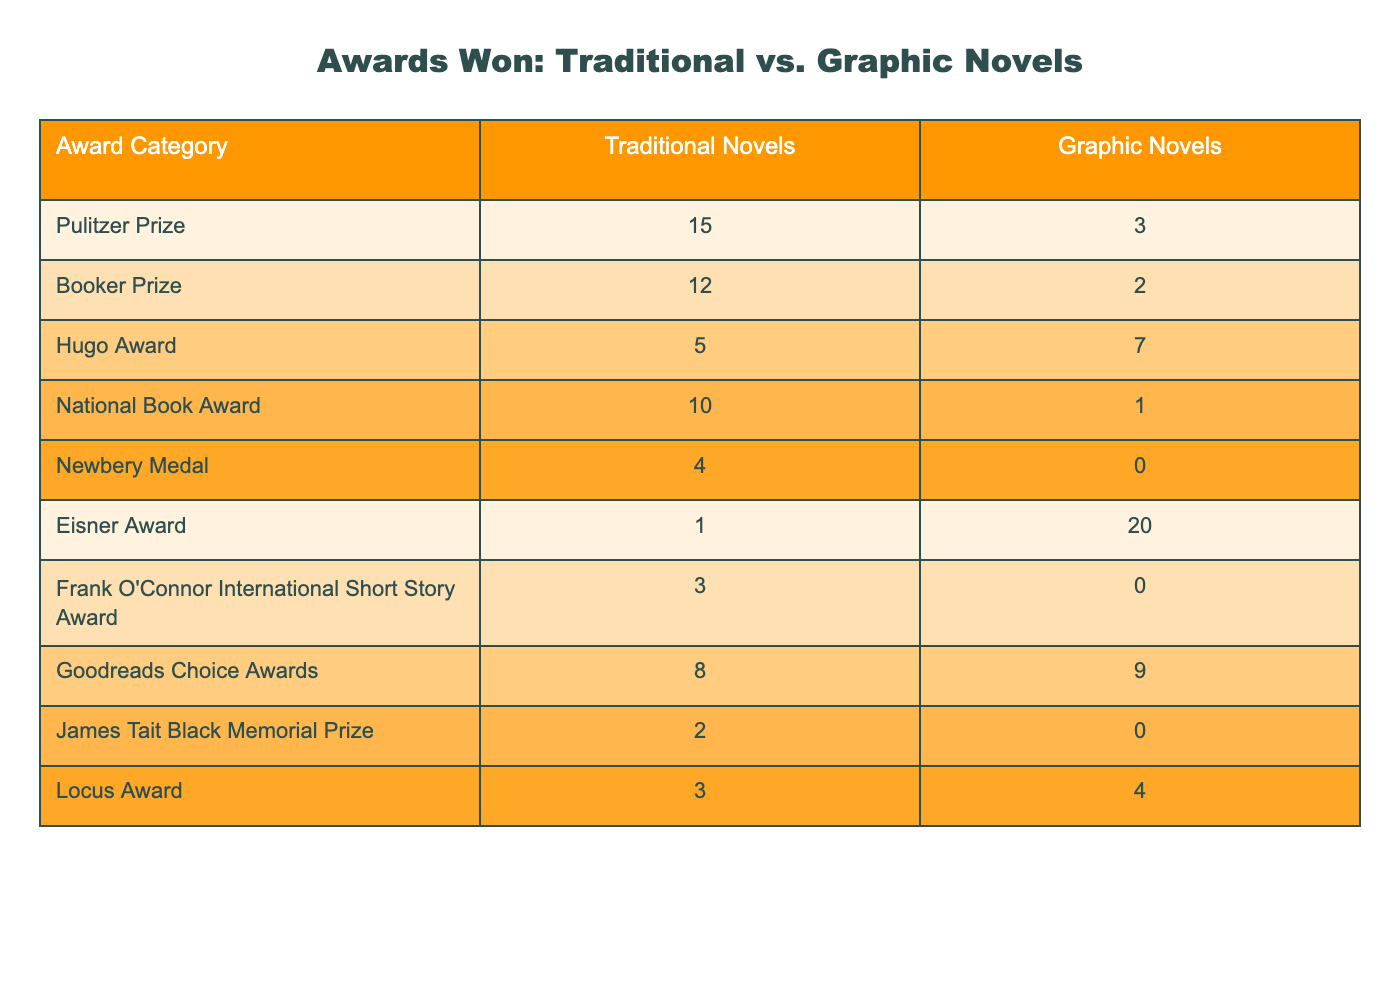What is the total number of Pulitzer Prizes won by traditional novels and graphic novels combined? The table shows that traditional novels won 15 Pulitzer Prizes and graphic novels won 3. Adding those values together (15 + 3) gives a total of 18.
Answer: 18 Which category has the highest number of awards won by traditional novels? By examining the table, the Pulitzer Prize category has the highest count of 15 awards won by traditional novels, compared to other categories listed.
Answer: Pulitzer Prize What is the difference in the number of Hugo Awards won between graphic novels and traditional novels? Looking at the table, graphic novels won 7 Hugo Awards while traditional novels won 5. The difference is calculated by subtracting the number of traditional novel awards from graphic novel awards (7 - 5), resulting in 2 more awards won by graphic novels.
Answer: 2 Did traditional novels win any Eisner Awards? The table indicates that traditional novels won 1 Eisner Award. Therefore, the answer is yes, traditional novels did win awards in this category.
Answer: Yes What is the average number of awards won by traditional novels across all categories listed? To calculate the average, add the number of awards won in all categories by traditional novels: 15 + 12 + 5 + 10 + 4 + 1 + 3 + 8 + 2 + 3 = 63. Then, divide by the number of categories, which is 10, to find the average: 63 / 10 = 6.3.
Answer: 6.3 Which type of novel won the most National Book Awards? From the table, traditional novels won 10 National Book Awards and graphic novels won 1 award in this category. Hence, traditional novels won the most.
Answer: Traditional novels What proportion of the total Goodreads Choice Awards won were by graphic novels? The table shows that graphic novels won 9 out of the total 8 + 9 = 17 Goodreads Choice Awards. The proportion can be calculated by dividing the number won by graphic novels (9) by the total (17), giving us 9/17, which is approximately 0.529 or 52.9%.
Answer: 52.9% Based on the awards, do traditional novels have a greater overall success compared to graphic novels? Traditional novels won a total of 63 awards across categories, whereas graphic novels won a total of 43 awards (3 + 2 + 7 + 1 + 0 + 20 + 0 + 9 + 0 + 4 = 43). Since 63 > 43, traditional novels have experienced greater overall success as represented by these awards.
Answer: Yes What is the total number of awards won by graphic novels in the Eisner and Newbery categories? For graphic novels, the Eisner Award count is 20 and the Newbery Medal count is 0. Adding these two counts together (20 + 0), we get a total of 20 awards won by graphic novels in these categories.
Answer: 20 